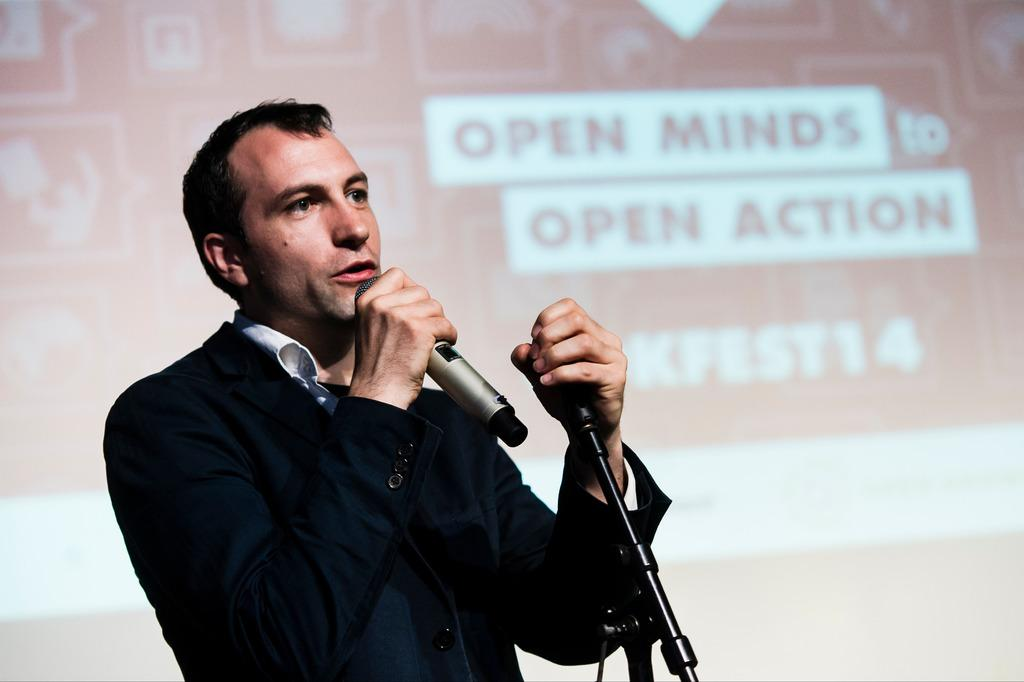Who is present in the image? There is a man in the image. What is the man doing in the image? The man is speaking in the image. What tool is the man using to amplify his voice? The man is using a microphone in the image. What can be seen in the background of the image? There is a projector screen in the background of the image. How many chairs are visible in the image? There are no chairs visible in the image. What type of crime is being committed in the image? There is no crime being committed in the image; it features a man speaking with a microphone and a projector screen in the background. 